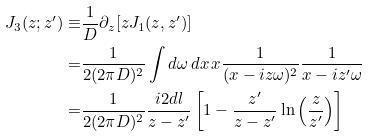<formula> <loc_0><loc_0><loc_500><loc_500>J _ { 3 } ( z ; z ^ { \prime } ) \equiv & \frac { 1 } { D } \partial _ { z } [ z J _ { 1 } ( z , z ^ { \prime } ) ] \\ = & \frac { 1 } { 2 ( 2 \pi D ) ^ { 2 } } \int d \omega \, d x \, x \frac { 1 } { ( x - i z \omega ) ^ { 2 } } \frac { 1 } { x - i z ^ { \prime } \omega } \\ = & \frac { 1 } { 2 ( 2 \pi D ) ^ { 2 } } \frac { i 2 d l } { z - z ^ { \prime } } \left [ 1 - \frac { z ^ { \prime } } { z - z ^ { \prime } } \ln \left ( \frac { z } { z ^ { \prime } } \right ) \right ]</formula> 